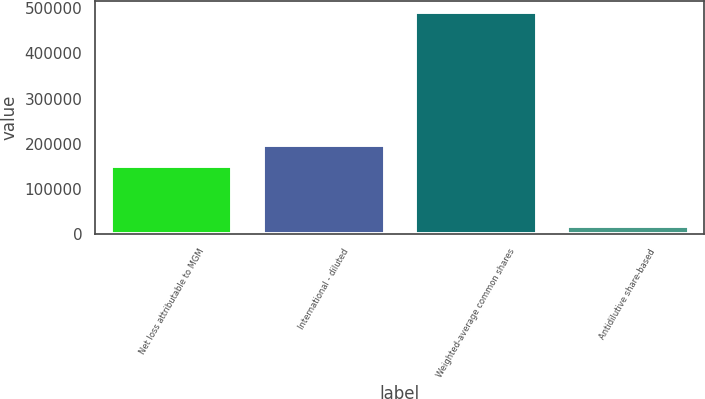Convert chart. <chart><loc_0><loc_0><loc_500><loc_500><bar_chart><fcel>Net loss attributable to MGM<fcel>International - diluted<fcel>Weighted-average common shares<fcel>Antidilutive share-based<nl><fcel>149873<fcel>197035<fcel>490875<fcel>19254<nl></chart> 